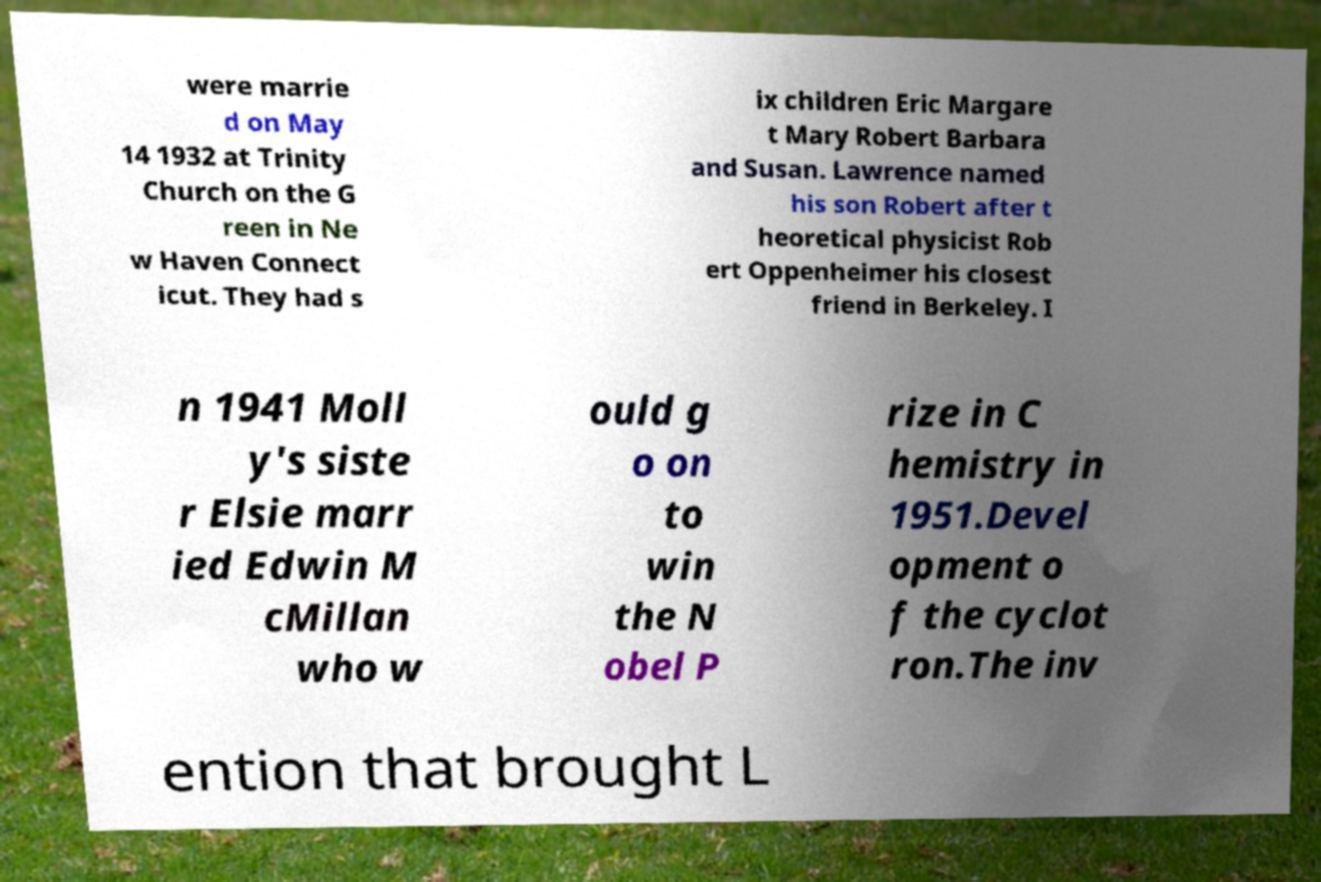Can you accurately transcribe the text from the provided image for me? were marrie d on May 14 1932 at Trinity Church on the G reen in Ne w Haven Connect icut. They had s ix children Eric Margare t Mary Robert Barbara and Susan. Lawrence named his son Robert after t heoretical physicist Rob ert Oppenheimer his closest friend in Berkeley. I n 1941 Moll y's siste r Elsie marr ied Edwin M cMillan who w ould g o on to win the N obel P rize in C hemistry in 1951.Devel opment o f the cyclot ron.The inv ention that brought L 